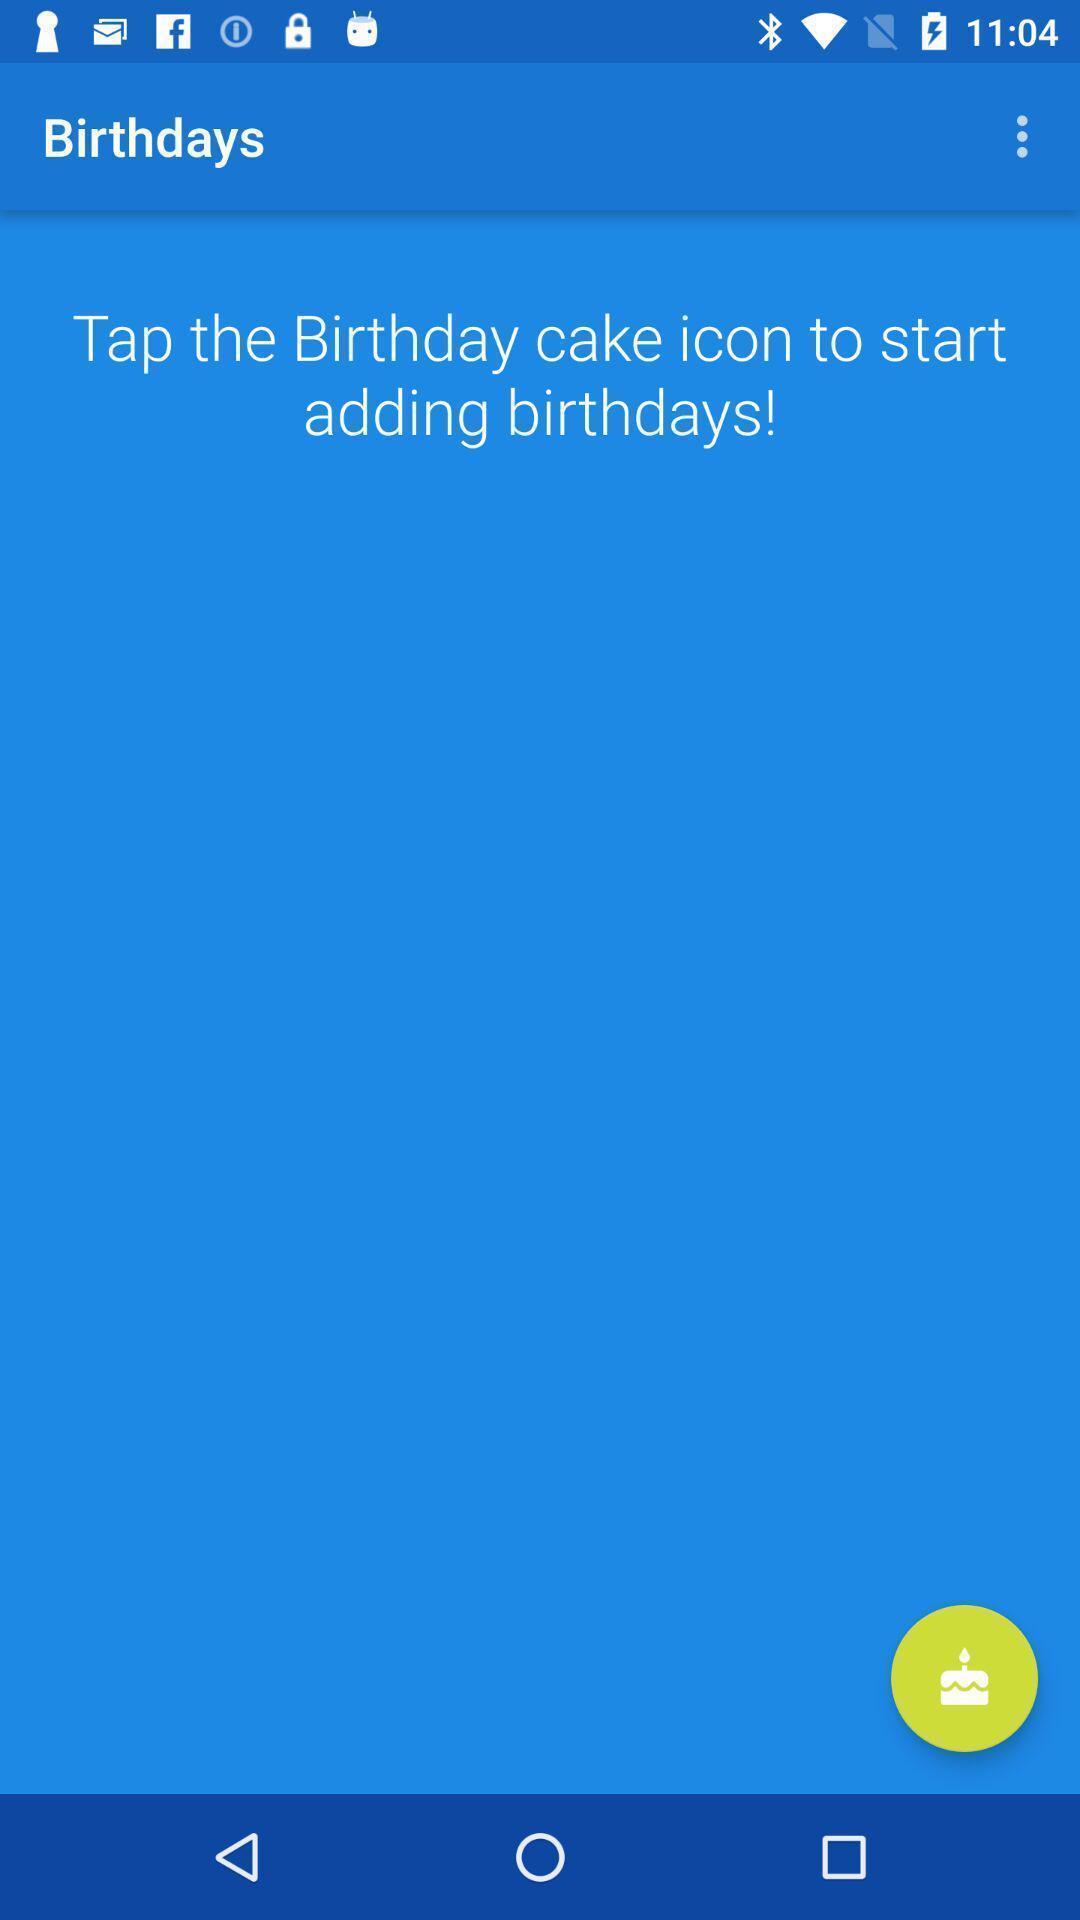What can you discern from this picture? Screen asking to add birthday events on a device. 